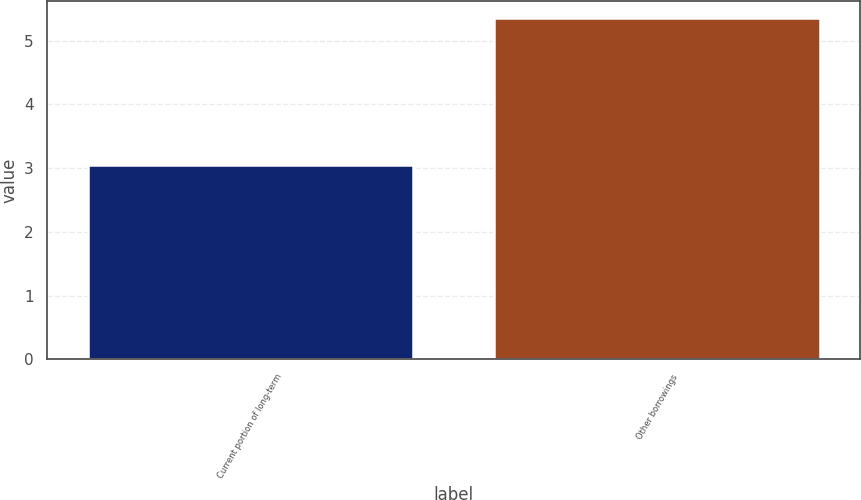<chart> <loc_0><loc_0><loc_500><loc_500><bar_chart><fcel>Current portion of long-term<fcel>Other borrowings<nl><fcel>3.05<fcel>5.35<nl></chart> 